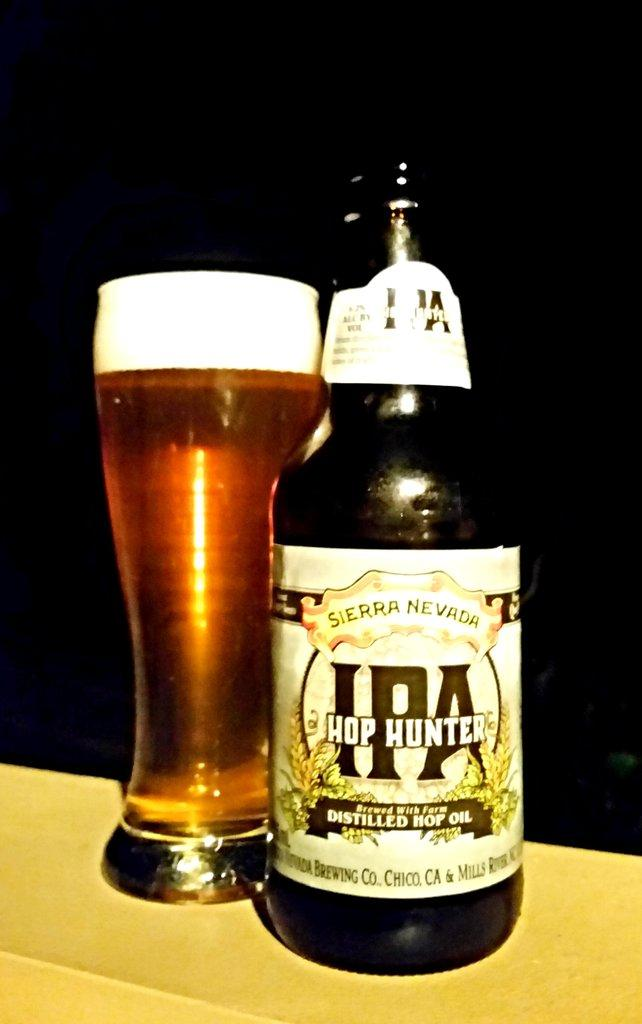<image>
Share a concise interpretation of the image provided. "HOP HUNTERS" is on the label of a bottle of beer. 